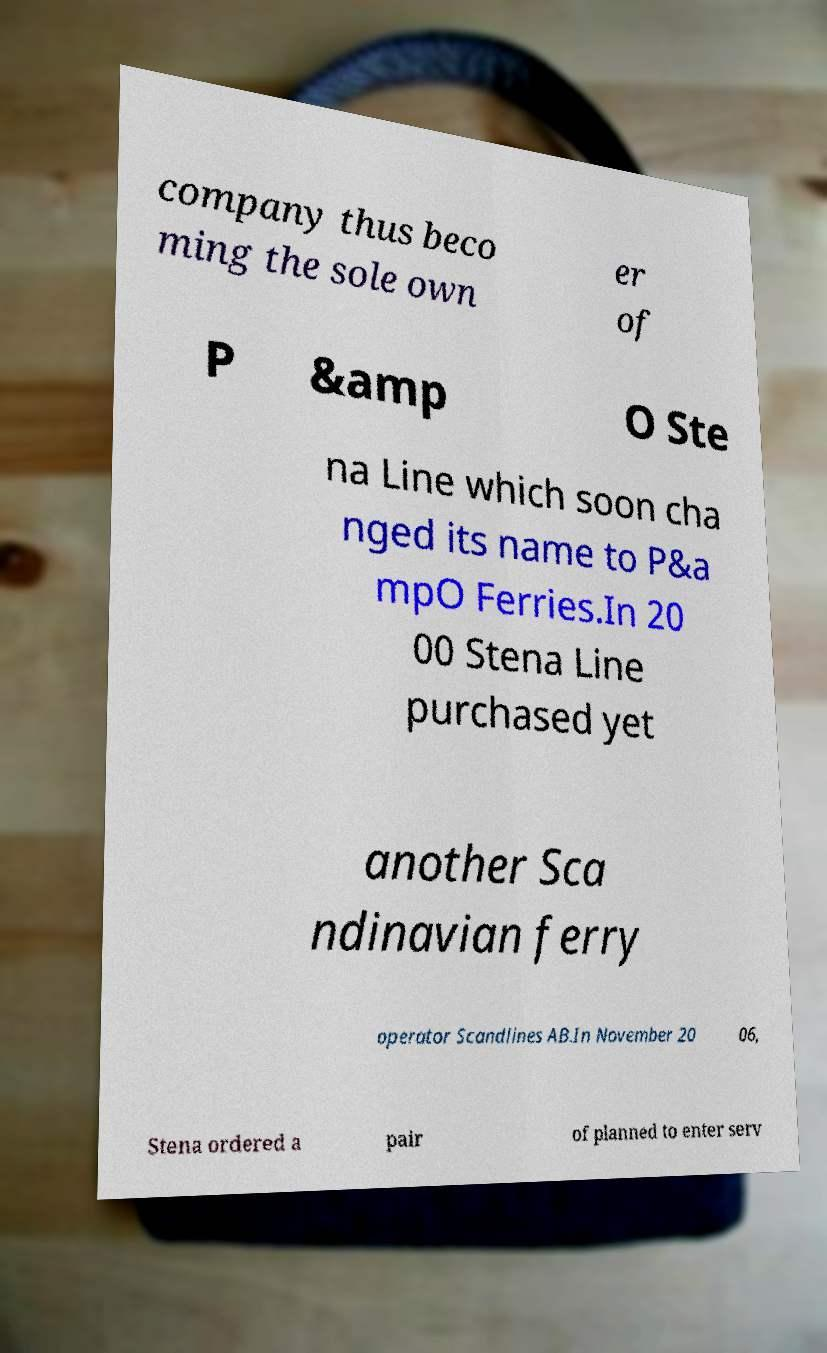Could you assist in decoding the text presented in this image and type it out clearly? company thus beco ming the sole own er of P &amp O Ste na Line which soon cha nged its name to P&a mpO Ferries.In 20 00 Stena Line purchased yet another Sca ndinavian ferry operator Scandlines AB.In November 20 06, Stena ordered a pair of planned to enter serv 